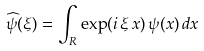Convert formula to latex. <formula><loc_0><loc_0><loc_500><loc_500>\widehat { \psi } ( \xi ) = \int _ { R } \exp ( i \, \xi \, x ) \, \psi ( x ) \, d x</formula> 